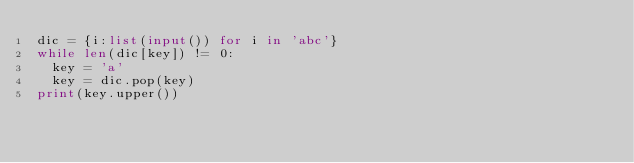<code> <loc_0><loc_0><loc_500><loc_500><_Python_>dic = {i:list(input()) for i in 'abc'}
while len(dic[key]) != 0:
  key = 'a'
  key = dic.pop(key)
print(key.upper())</code> 